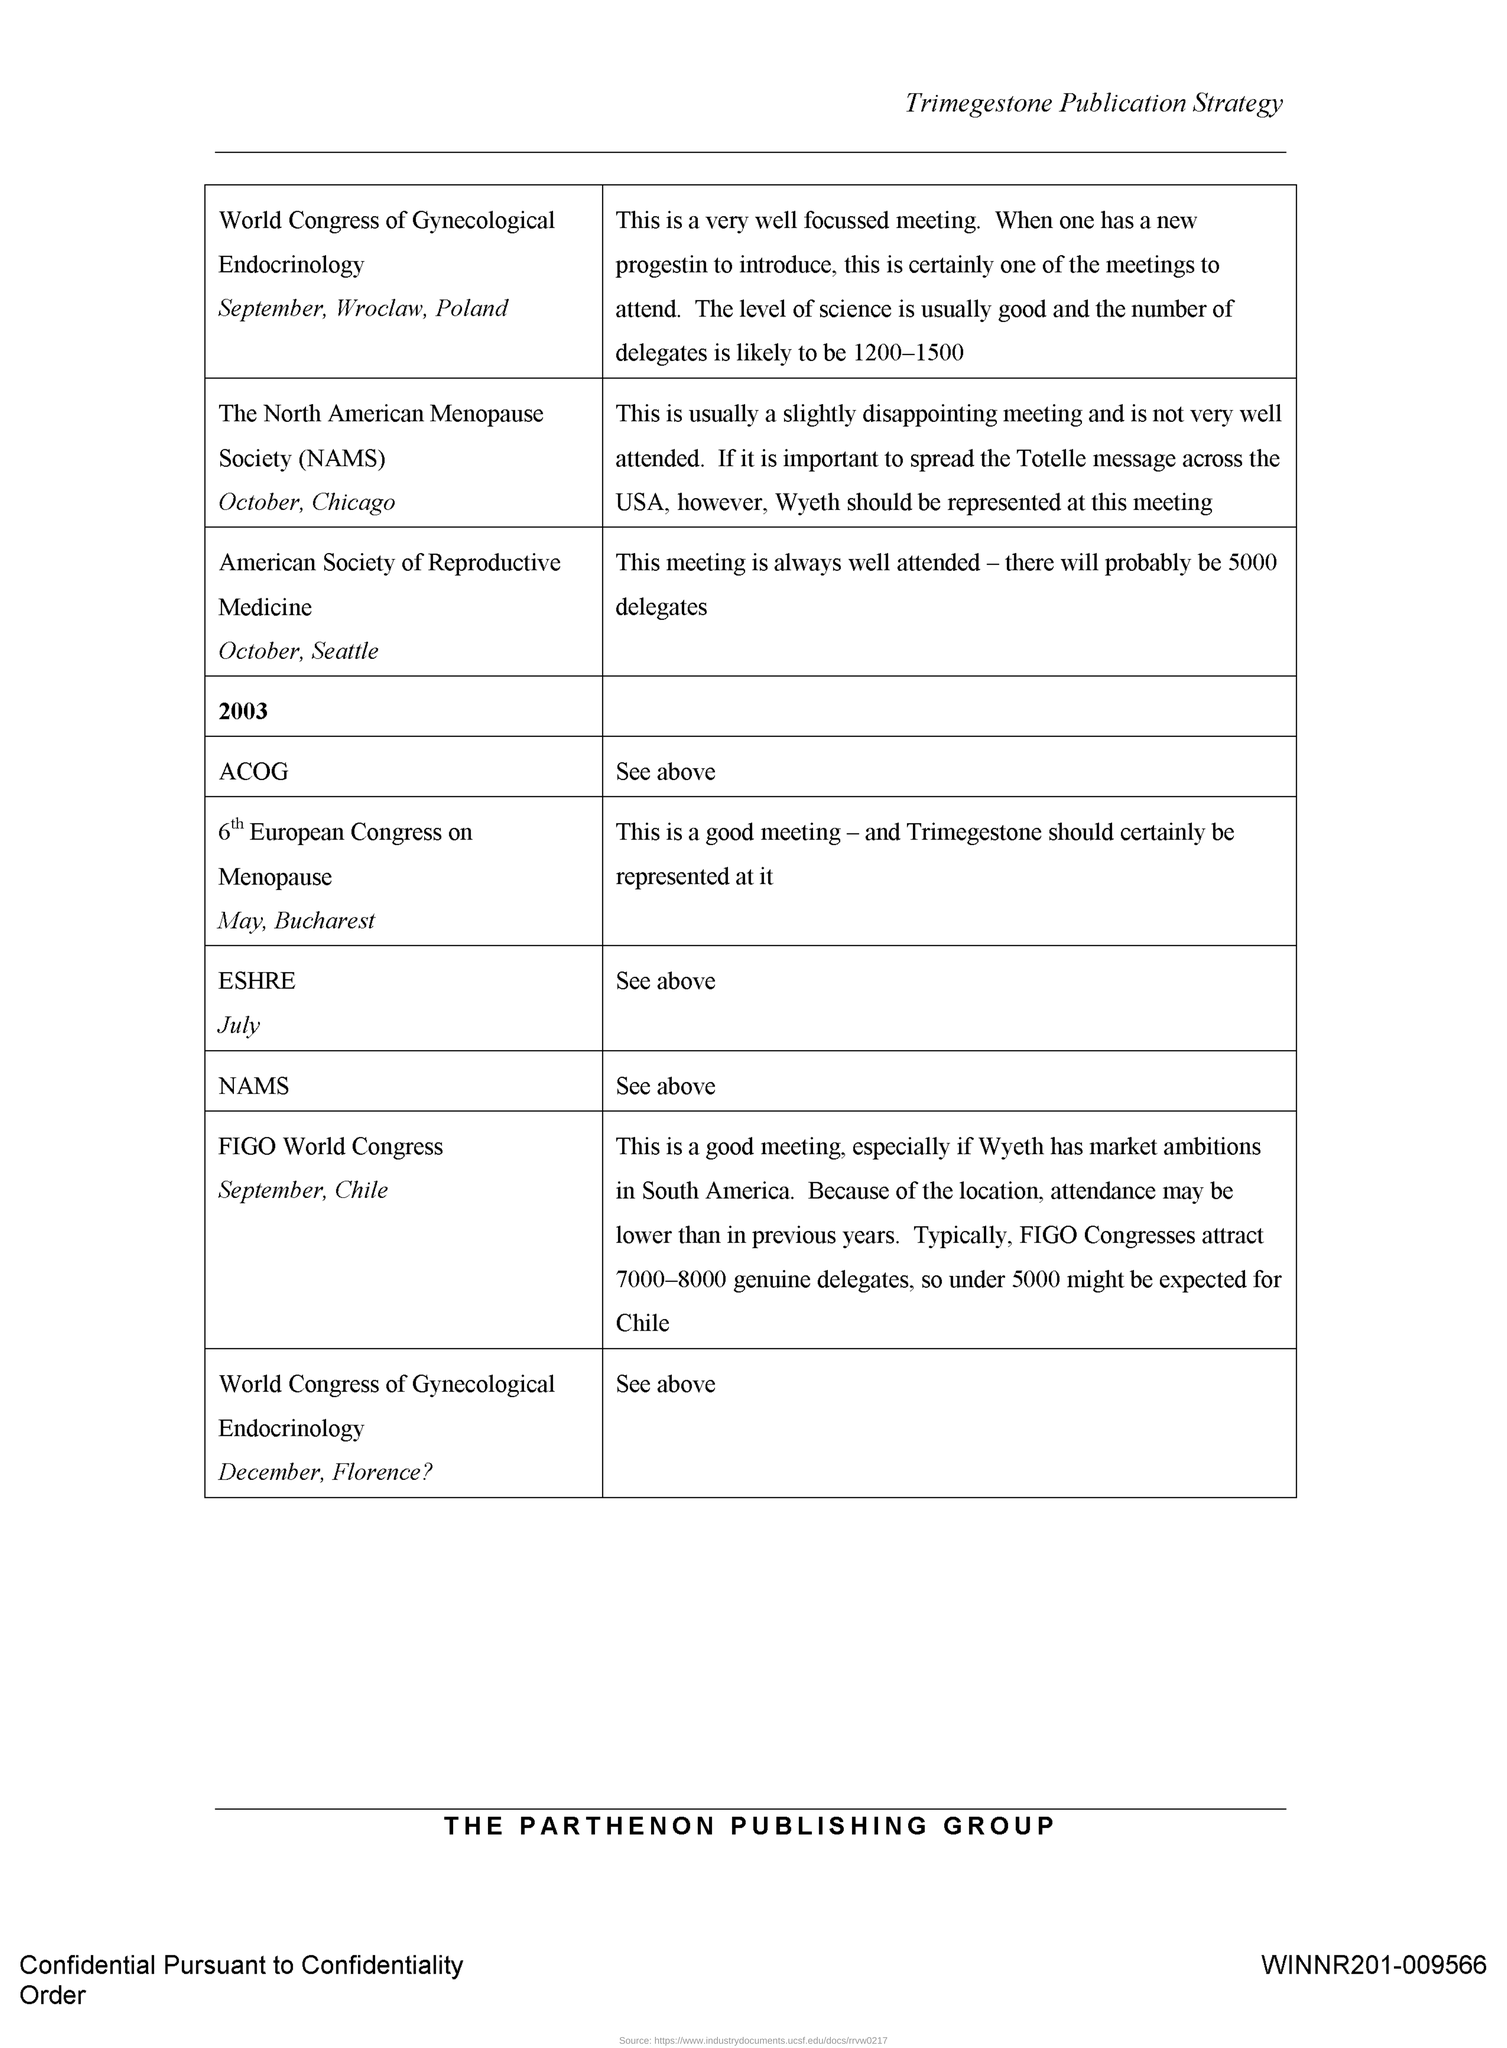What is the Title of the document?
Ensure brevity in your answer.  Trimegestone Publication Strategy. What is the Document Number?
Ensure brevity in your answer.  WINNR201-009566. 